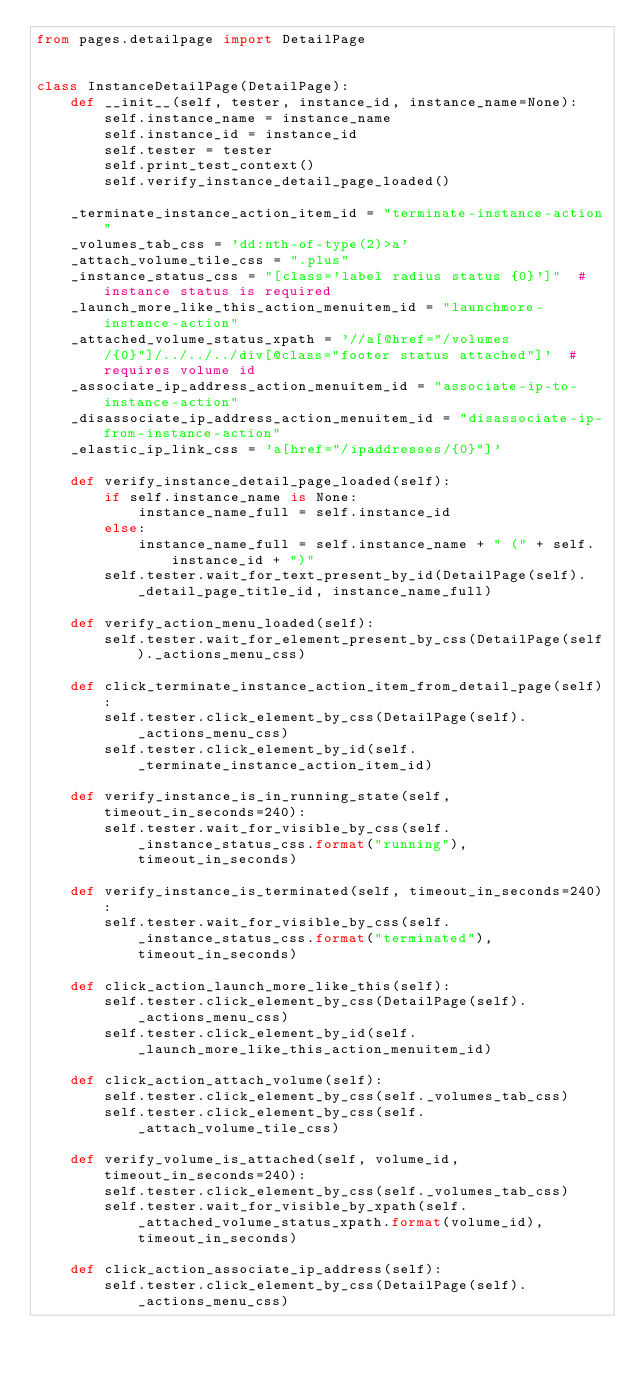Convert code to text. <code><loc_0><loc_0><loc_500><loc_500><_Python_>from pages.detailpage import DetailPage


class InstanceDetailPage(DetailPage):
    def __init__(self, tester, instance_id, instance_name=None):
        self.instance_name = instance_name
        self.instance_id = instance_id
        self.tester = tester
        self.print_test_context()
        self.verify_instance_detail_page_loaded()

    _terminate_instance_action_item_id = "terminate-instance-action"
    _volumes_tab_css = 'dd:nth-of-type(2)>a'
    _attach_volume_tile_css = ".plus"
    _instance_status_css = "[class='label radius status {0}']"  # instance status is required
    _launch_more_like_this_action_menuitem_id = "launchmore-instance-action"
    _attached_volume_status_xpath = '//a[@href="/volumes/{0}"]/../../../div[@class="footer status attached"]'  # requires volume id
    _associate_ip_address_action_menuitem_id = "associate-ip-to-instance-action"
    _disassociate_ip_address_action_menuitem_id = "disassociate-ip-from-instance-action"
    _elastic_ip_link_css = 'a[href="/ipaddresses/{0}"]'

    def verify_instance_detail_page_loaded(self):
        if self.instance_name is None:
            instance_name_full = self.instance_id
        else:
            instance_name_full = self.instance_name + " (" + self.instance_id + ")"
        self.tester.wait_for_text_present_by_id(DetailPage(self)._detail_page_title_id, instance_name_full)

    def verify_action_menu_loaded(self):
        self.tester.wait_for_element_present_by_css(DetailPage(self)._actions_menu_css)

    def click_terminate_instance_action_item_from_detail_page(self):
        self.tester.click_element_by_css(DetailPage(self)._actions_menu_css)
        self.tester.click_element_by_id(self._terminate_instance_action_item_id)

    def verify_instance_is_in_running_state(self, timeout_in_seconds=240):
        self.tester.wait_for_visible_by_css(self._instance_status_css.format("running"), timeout_in_seconds)

    def verify_instance_is_terminated(self, timeout_in_seconds=240):
        self.tester.wait_for_visible_by_css(self._instance_status_css.format("terminated"), timeout_in_seconds)

    def click_action_launch_more_like_this(self):
        self.tester.click_element_by_css(DetailPage(self)._actions_menu_css)
        self.tester.click_element_by_id(self._launch_more_like_this_action_menuitem_id)

    def click_action_attach_volume(self):
        self.tester.click_element_by_css(self._volumes_tab_css)
        self.tester.click_element_by_css(self._attach_volume_tile_css)

    def verify_volume_is_attached(self, volume_id, timeout_in_seconds=240):
        self.tester.click_element_by_css(self._volumes_tab_css)
        self.tester.wait_for_visible_by_xpath(self._attached_volume_status_xpath.format(volume_id), timeout_in_seconds)

    def click_action_associate_ip_address(self):
        self.tester.click_element_by_css(DetailPage(self)._actions_menu_css)</code> 